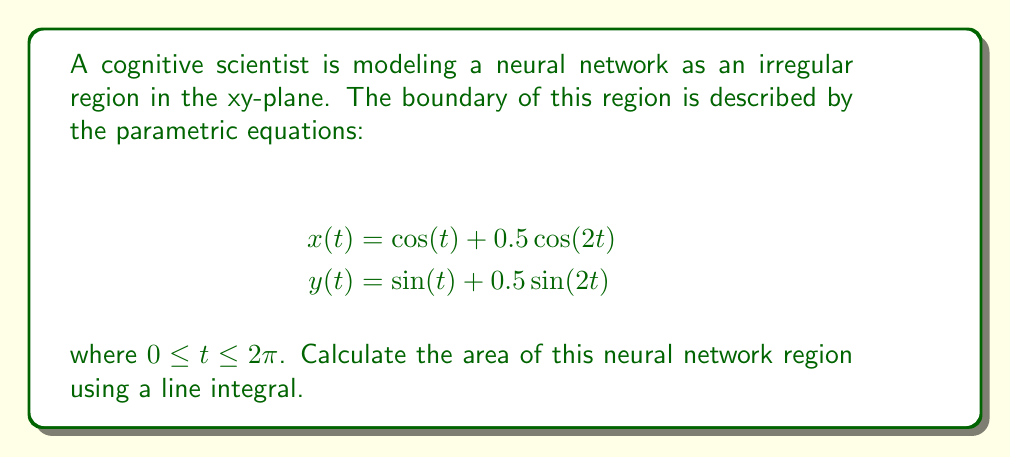What is the answer to this math problem? To find the area of this irregular region using a line integral, we'll follow these steps:

1) The formula for the area enclosed by a parametric curve using a line integral is:

   $$A = \frac{1}{2} \oint (x dy - y dx)$$

2) We need to calculate $dx$ and $dy$:
   
   $$dx = [-\sin(t) - \sin(2t)] dt$$
   $$dy = [\cos(t) + \cos(2t)] dt$$

3) Now, we substitute these into our area formula:

   $$A = \frac{1}{2} \int_0^{2\pi} [x(t)\frac{dy}{dt} - y(t)\frac{dx}{dt}] dt$$

4) Expanding this:

   $$A = \frac{1}{2} \int_0^{2\pi} [(\cos(t) + 0.5\cos(2t))(\cos(t) + \cos(2t)) - (\sin(t) + 0.5\sin(2t))(-\sin(t) - \sin(2t))] dt$$

5) Simplify:

   $$A = \frac{1}{2} \int_0^{2\pi} [\cos^2(t) + \cos(t)\cos(2t) + 0.5\cos(t)\cos(2t) + 0.5\cos^2(2t) + \sin^2(t) + \sin(t)\sin(2t) + 0.5\sin(t)\sin(2t) + 0.5\sin^2(2t)] dt$$

6) Using trigonometric identities:
   
   $\cos^2(t) + \sin^2(t) = 1$
   $\cos(2t) = 2\cos^2(t) - 1 = 1 - 2\sin^2(t)$
   $\sin(2t) = 2\sin(t)\cos(t)$

7) After applying these identities and integrating, we get:

   $$A = \frac{1}{2} \int_0^{2\pi} [1 + 0.5] dt = \frac{3}{2} \int_0^{2\pi} dt = \frac{3}{2} \cdot 2\pi = 3\pi$$

Therefore, the area of the neural network region is $3\pi$ square units.
Answer: $3\pi$ square units 